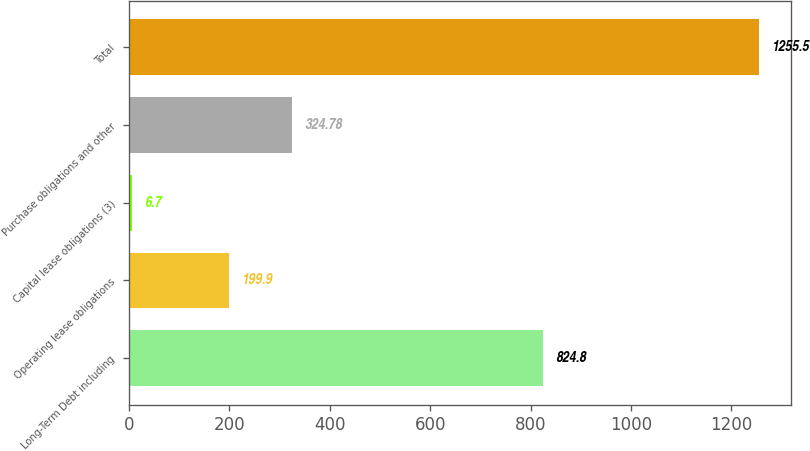Convert chart to OTSL. <chart><loc_0><loc_0><loc_500><loc_500><bar_chart><fcel>Long-Term Debt including<fcel>Operating lease obligations<fcel>Capital lease obligations (3)<fcel>Purchase obligations and other<fcel>Total<nl><fcel>824.8<fcel>199.9<fcel>6.7<fcel>324.78<fcel>1255.5<nl></chart> 